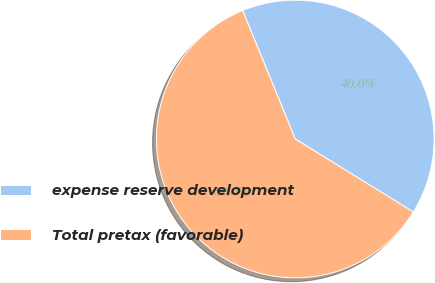Convert chart to OTSL. <chart><loc_0><loc_0><loc_500><loc_500><pie_chart><fcel>expense reserve development<fcel>Total pretax (favorable)<nl><fcel>40.0%<fcel>60.0%<nl></chart> 